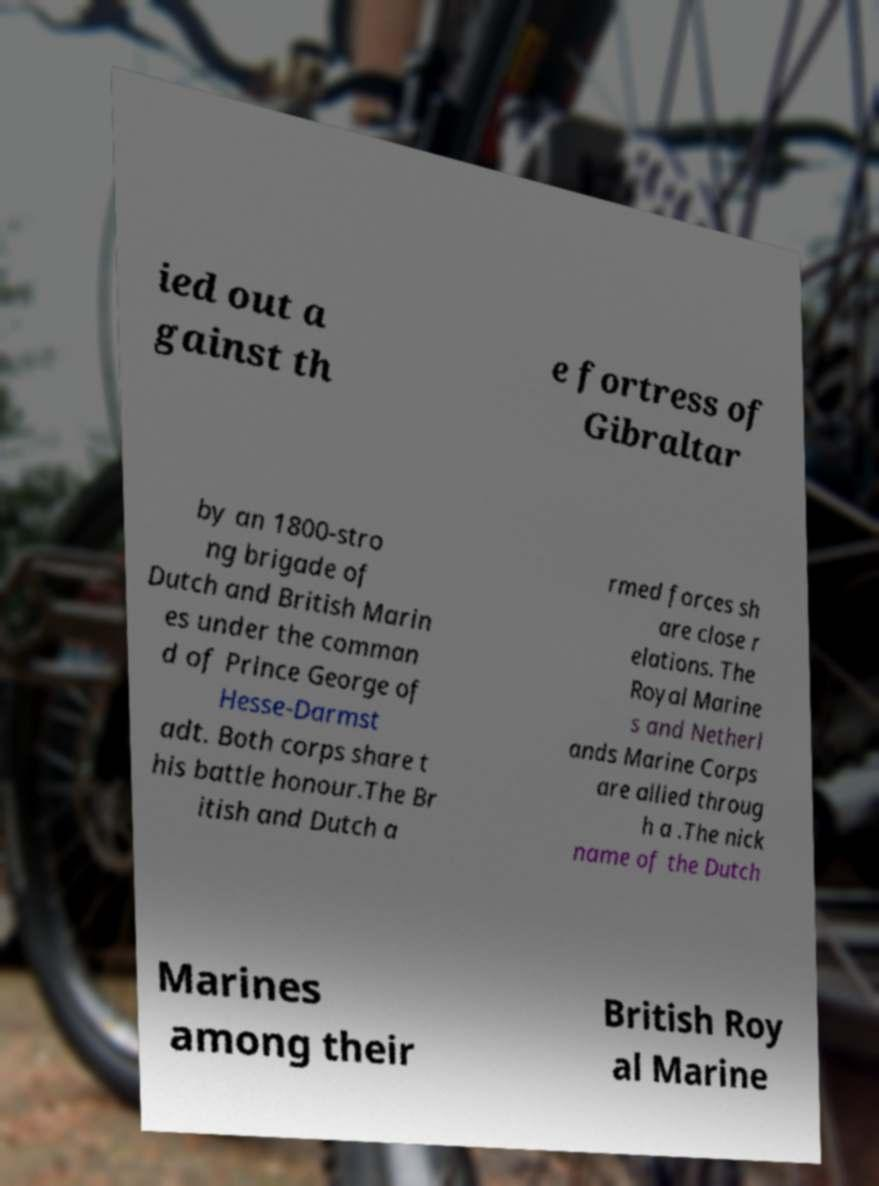For documentation purposes, I need the text within this image transcribed. Could you provide that? ied out a gainst th e fortress of Gibraltar by an 1800-stro ng brigade of Dutch and British Marin es under the comman d of Prince George of Hesse-Darmst adt. Both corps share t his battle honour.The Br itish and Dutch a rmed forces sh are close r elations. The Royal Marine s and Netherl ands Marine Corps are allied throug h a .The nick name of the Dutch Marines among their British Roy al Marine 